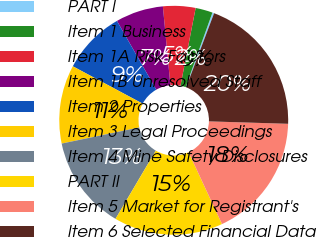Convert chart. <chart><loc_0><loc_0><loc_500><loc_500><pie_chart><fcel>PART I<fcel>Item 1 Business<fcel>Item 1A Risk Factors<fcel>Item 1B Unresolved Staff<fcel>Item 2 Properties<fcel>Item 3 Legal Proceedings<fcel>Item 4 Mine Safety Disclosures<fcel>PART II<fcel>Item 5 Market for Registrant's<fcel>Item 6 Selected Financial Data<nl><fcel>0.25%<fcel>2.42%<fcel>4.58%<fcel>6.75%<fcel>8.92%<fcel>11.08%<fcel>13.25%<fcel>15.42%<fcel>17.58%<fcel>19.75%<nl></chart> 